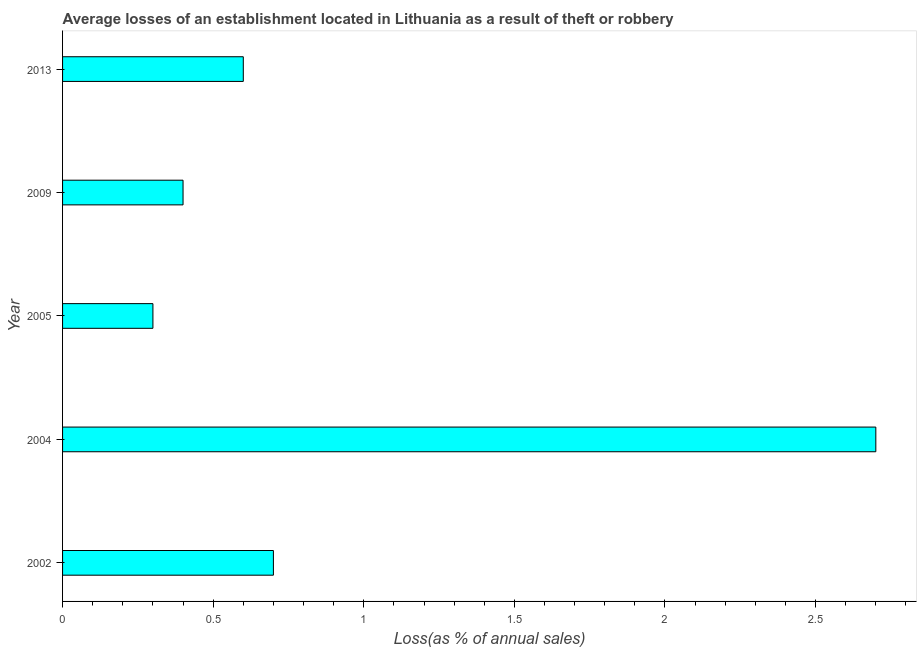What is the title of the graph?
Your answer should be compact. Average losses of an establishment located in Lithuania as a result of theft or robbery. What is the label or title of the X-axis?
Offer a terse response. Loss(as % of annual sales). What is the losses due to theft in 2009?
Your answer should be very brief. 0.4. What is the difference between the losses due to theft in 2002 and 2009?
Provide a succinct answer. 0.3. What is the ratio of the losses due to theft in 2004 to that in 2013?
Ensure brevity in your answer.  4.5. Is the losses due to theft in 2002 less than that in 2004?
Your answer should be compact. Yes. Is the difference between the losses due to theft in 2002 and 2009 greater than the difference between any two years?
Give a very brief answer. No. In how many years, is the losses due to theft greater than the average losses due to theft taken over all years?
Make the answer very short. 1. Are all the bars in the graph horizontal?
Give a very brief answer. Yes. What is the Loss(as % of annual sales) of 2004?
Provide a short and direct response. 2.7. What is the Loss(as % of annual sales) of 2005?
Provide a succinct answer. 0.3. What is the Loss(as % of annual sales) of 2013?
Offer a very short reply. 0.6. What is the difference between the Loss(as % of annual sales) in 2002 and 2004?
Give a very brief answer. -2. What is the difference between the Loss(as % of annual sales) in 2002 and 2005?
Ensure brevity in your answer.  0.4. What is the difference between the Loss(as % of annual sales) in 2002 and 2013?
Ensure brevity in your answer.  0.1. What is the difference between the Loss(as % of annual sales) in 2004 and 2013?
Your answer should be compact. 2.1. What is the difference between the Loss(as % of annual sales) in 2005 and 2009?
Give a very brief answer. -0.1. What is the ratio of the Loss(as % of annual sales) in 2002 to that in 2004?
Provide a short and direct response. 0.26. What is the ratio of the Loss(as % of annual sales) in 2002 to that in 2005?
Offer a terse response. 2.33. What is the ratio of the Loss(as % of annual sales) in 2002 to that in 2013?
Offer a very short reply. 1.17. What is the ratio of the Loss(as % of annual sales) in 2004 to that in 2005?
Offer a terse response. 9. What is the ratio of the Loss(as % of annual sales) in 2004 to that in 2009?
Your answer should be compact. 6.75. What is the ratio of the Loss(as % of annual sales) in 2004 to that in 2013?
Keep it short and to the point. 4.5. What is the ratio of the Loss(as % of annual sales) in 2005 to that in 2013?
Provide a short and direct response. 0.5. What is the ratio of the Loss(as % of annual sales) in 2009 to that in 2013?
Offer a very short reply. 0.67. 